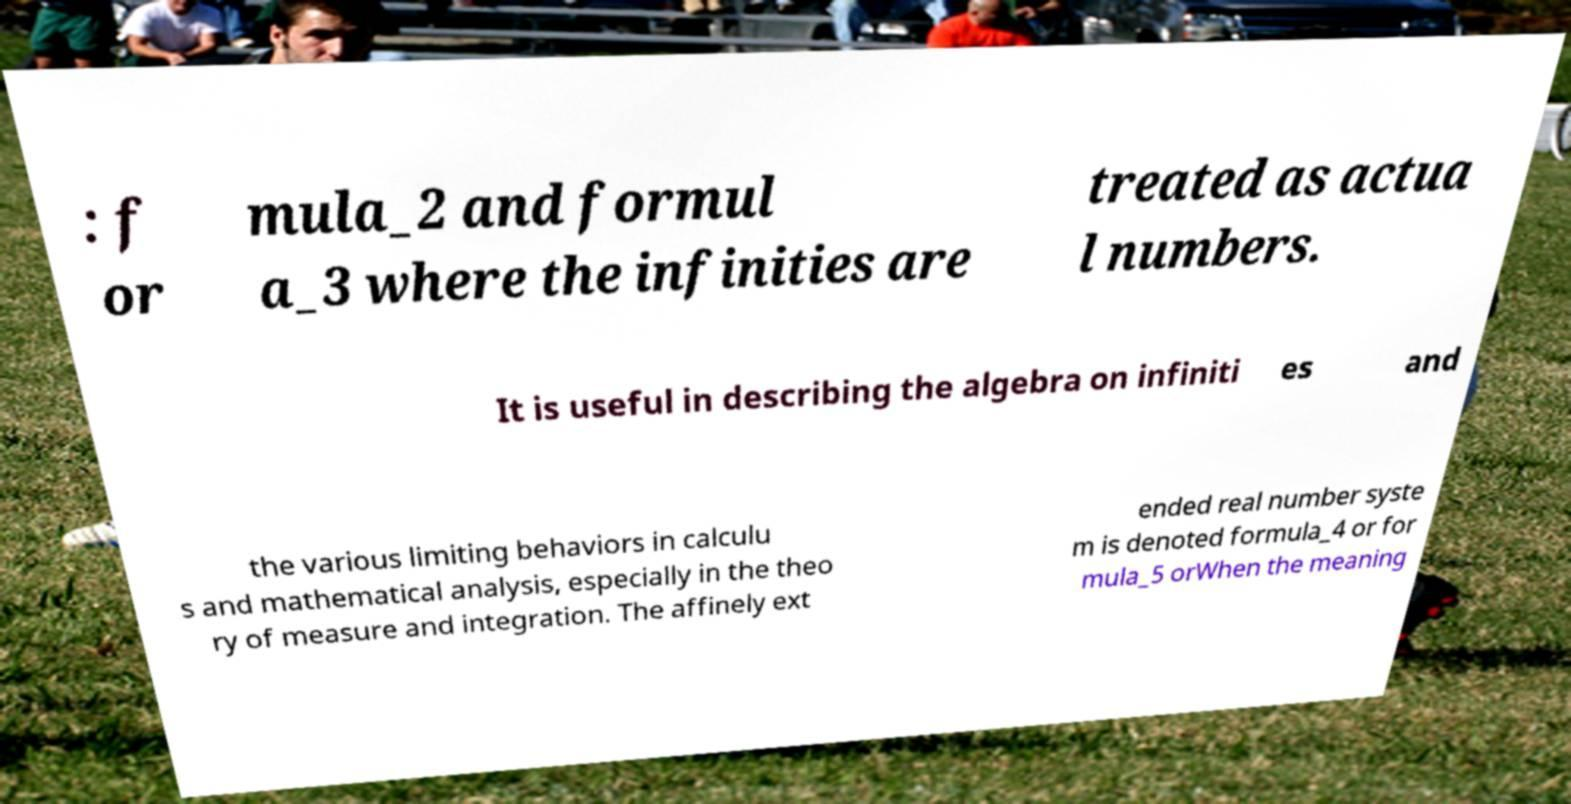Can you accurately transcribe the text from the provided image for me? : f or mula_2 and formul a_3 where the infinities are treated as actua l numbers. It is useful in describing the algebra on infiniti es and the various limiting behaviors in calculu s and mathematical analysis, especially in the theo ry of measure and integration. The affinely ext ended real number syste m is denoted formula_4 or for mula_5 orWhen the meaning 